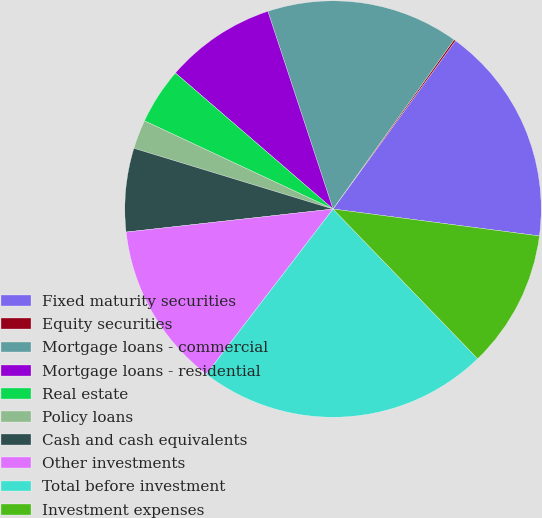Convert chart to OTSL. <chart><loc_0><loc_0><loc_500><loc_500><pie_chart><fcel>Fixed maturity securities<fcel>Equity securities<fcel>Mortgage loans - commercial<fcel>Mortgage loans - residential<fcel>Real estate<fcel>Policy loans<fcel>Cash and cash equivalents<fcel>Other investments<fcel>Total before investment<fcel>Investment expenses<nl><fcel>17.05%<fcel>0.14%<fcel>14.94%<fcel>8.6%<fcel>4.37%<fcel>2.25%<fcel>6.48%<fcel>12.82%<fcel>22.64%<fcel>10.71%<nl></chart> 